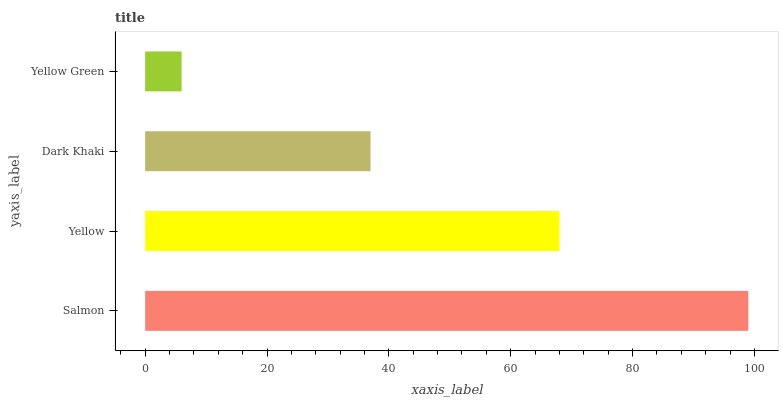Is Yellow Green the minimum?
Answer yes or no. Yes. Is Salmon the maximum?
Answer yes or no. Yes. Is Yellow the minimum?
Answer yes or no. No. Is Yellow the maximum?
Answer yes or no. No. Is Salmon greater than Yellow?
Answer yes or no. Yes. Is Yellow less than Salmon?
Answer yes or no. Yes. Is Yellow greater than Salmon?
Answer yes or no. No. Is Salmon less than Yellow?
Answer yes or no. No. Is Yellow the high median?
Answer yes or no. Yes. Is Dark Khaki the low median?
Answer yes or no. Yes. Is Dark Khaki the high median?
Answer yes or no. No. Is Yellow the low median?
Answer yes or no. No. 